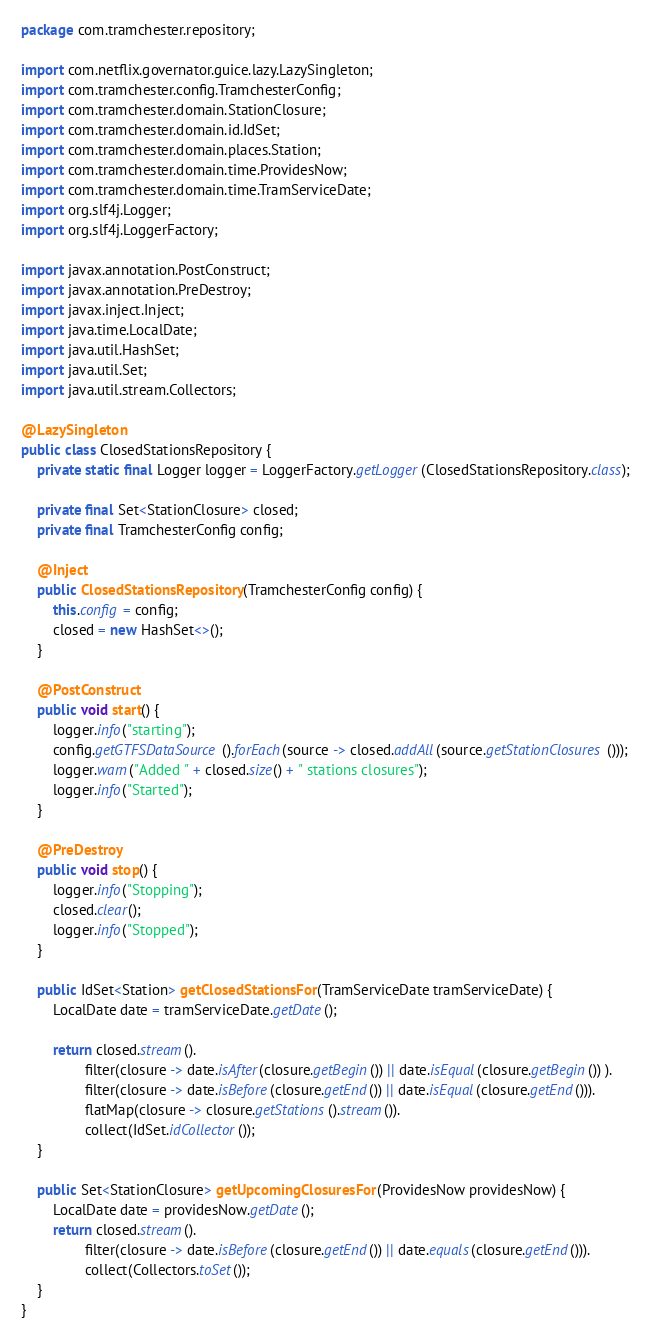<code> <loc_0><loc_0><loc_500><loc_500><_Java_>package com.tramchester.repository;

import com.netflix.governator.guice.lazy.LazySingleton;
import com.tramchester.config.TramchesterConfig;
import com.tramchester.domain.StationClosure;
import com.tramchester.domain.id.IdSet;
import com.tramchester.domain.places.Station;
import com.tramchester.domain.time.ProvidesNow;
import com.tramchester.domain.time.TramServiceDate;
import org.slf4j.Logger;
import org.slf4j.LoggerFactory;

import javax.annotation.PostConstruct;
import javax.annotation.PreDestroy;
import javax.inject.Inject;
import java.time.LocalDate;
import java.util.HashSet;
import java.util.Set;
import java.util.stream.Collectors;

@LazySingleton
public class ClosedStationsRepository {
    private static final Logger logger = LoggerFactory.getLogger(ClosedStationsRepository.class);

    private final Set<StationClosure> closed;
    private final TramchesterConfig config;

    @Inject
    public ClosedStationsRepository(TramchesterConfig config) {
        this.config = config;
        closed = new HashSet<>();
    }

    @PostConstruct
    public void start() {
        logger.info("starting");
        config.getGTFSDataSource().forEach(source -> closed.addAll(source.getStationClosures()));
        logger.warn("Added " + closed.size() + " stations closures");
        logger.info("Started");
    }

    @PreDestroy
    public void stop() {
        logger.info("Stopping");
        closed.clear();
        logger.info("Stopped");
    }

    public IdSet<Station> getClosedStationsFor(TramServiceDate tramServiceDate) {
        LocalDate date = tramServiceDate.getDate();

        return closed.stream().
                filter(closure -> date.isAfter(closure.getBegin()) || date.isEqual(closure.getBegin()) ).
                filter(closure -> date.isBefore(closure.getEnd()) || date.isEqual(closure.getEnd())).
                flatMap(closure -> closure.getStations().stream()).
                collect(IdSet.idCollector());
    }

    public Set<StationClosure> getUpcomingClosuresFor(ProvidesNow providesNow) {
        LocalDate date = providesNow.getDate();
        return closed.stream().
                filter(closure -> date.isBefore(closure.getEnd()) || date.equals(closure.getEnd())).
                collect(Collectors.toSet());
    }
}
</code> 